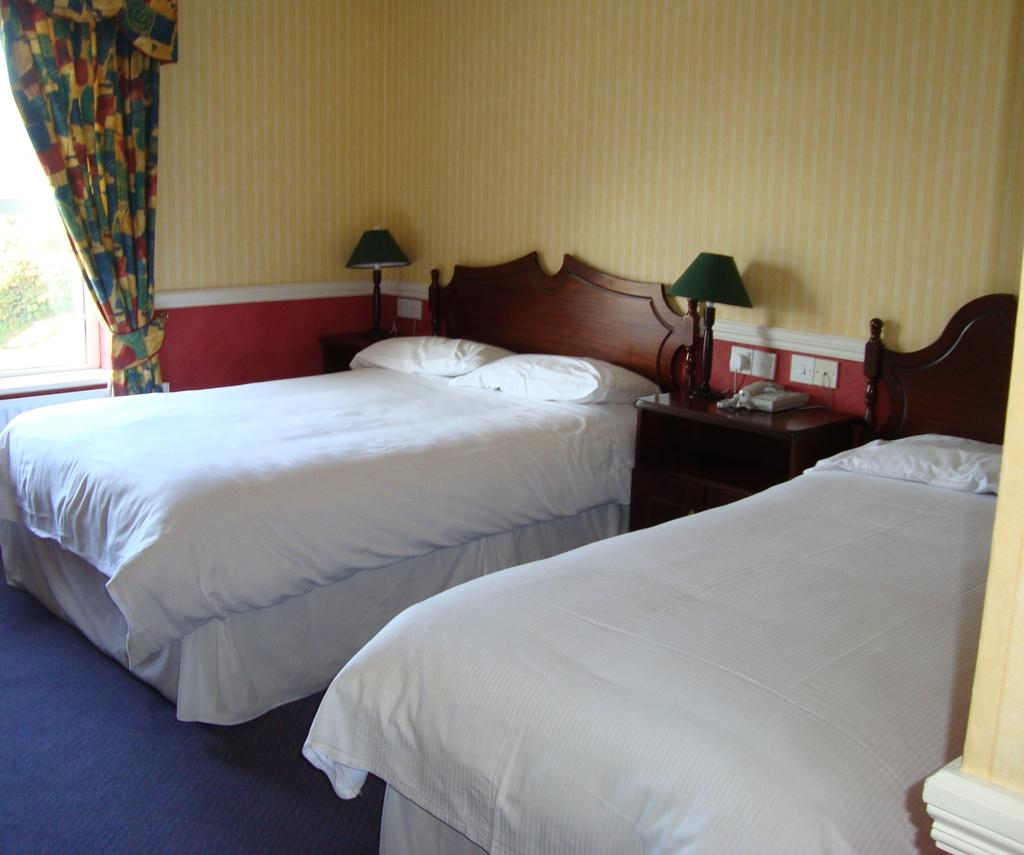How many beds are visible in the image? There are two empty beds in the image. What is the color of the beds? The beds are white in color. What can be seen in the background of the image? There is a beautiful curtain and two bed lamps in the background of the image. What type of potato is being used as a pillow on one of the beds? There is no potato present in the image, and the beds do not have pillows. 